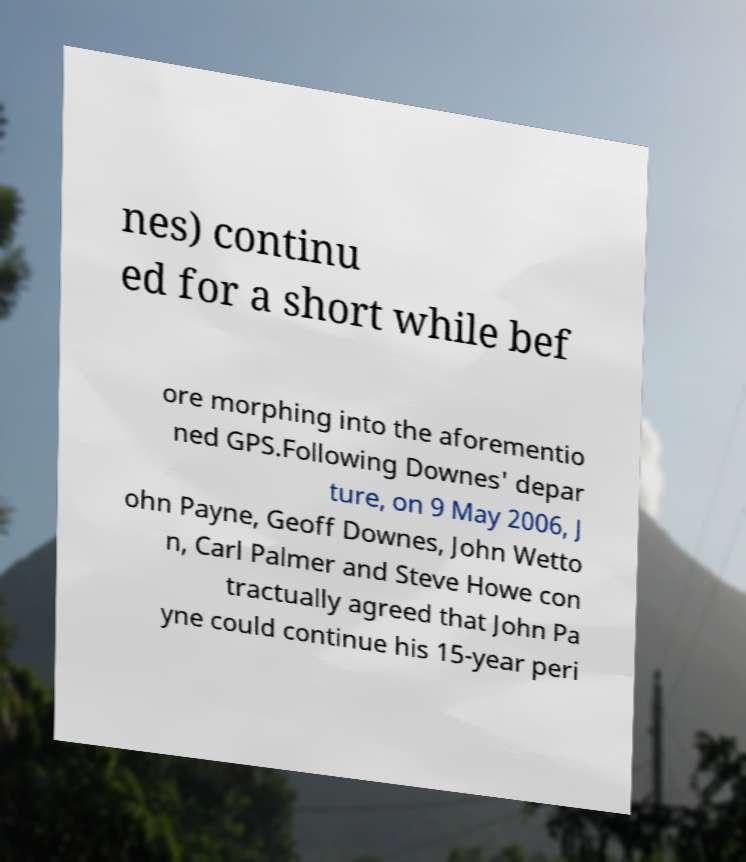Can you read and provide the text displayed in the image?This photo seems to have some interesting text. Can you extract and type it out for me? nes) continu ed for a short while bef ore morphing into the aforementio ned GPS.Following Downes' depar ture, on 9 May 2006, J ohn Payne, Geoff Downes, John Wetto n, Carl Palmer and Steve Howe con tractually agreed that John Pa yne could continue his 15-year peri 